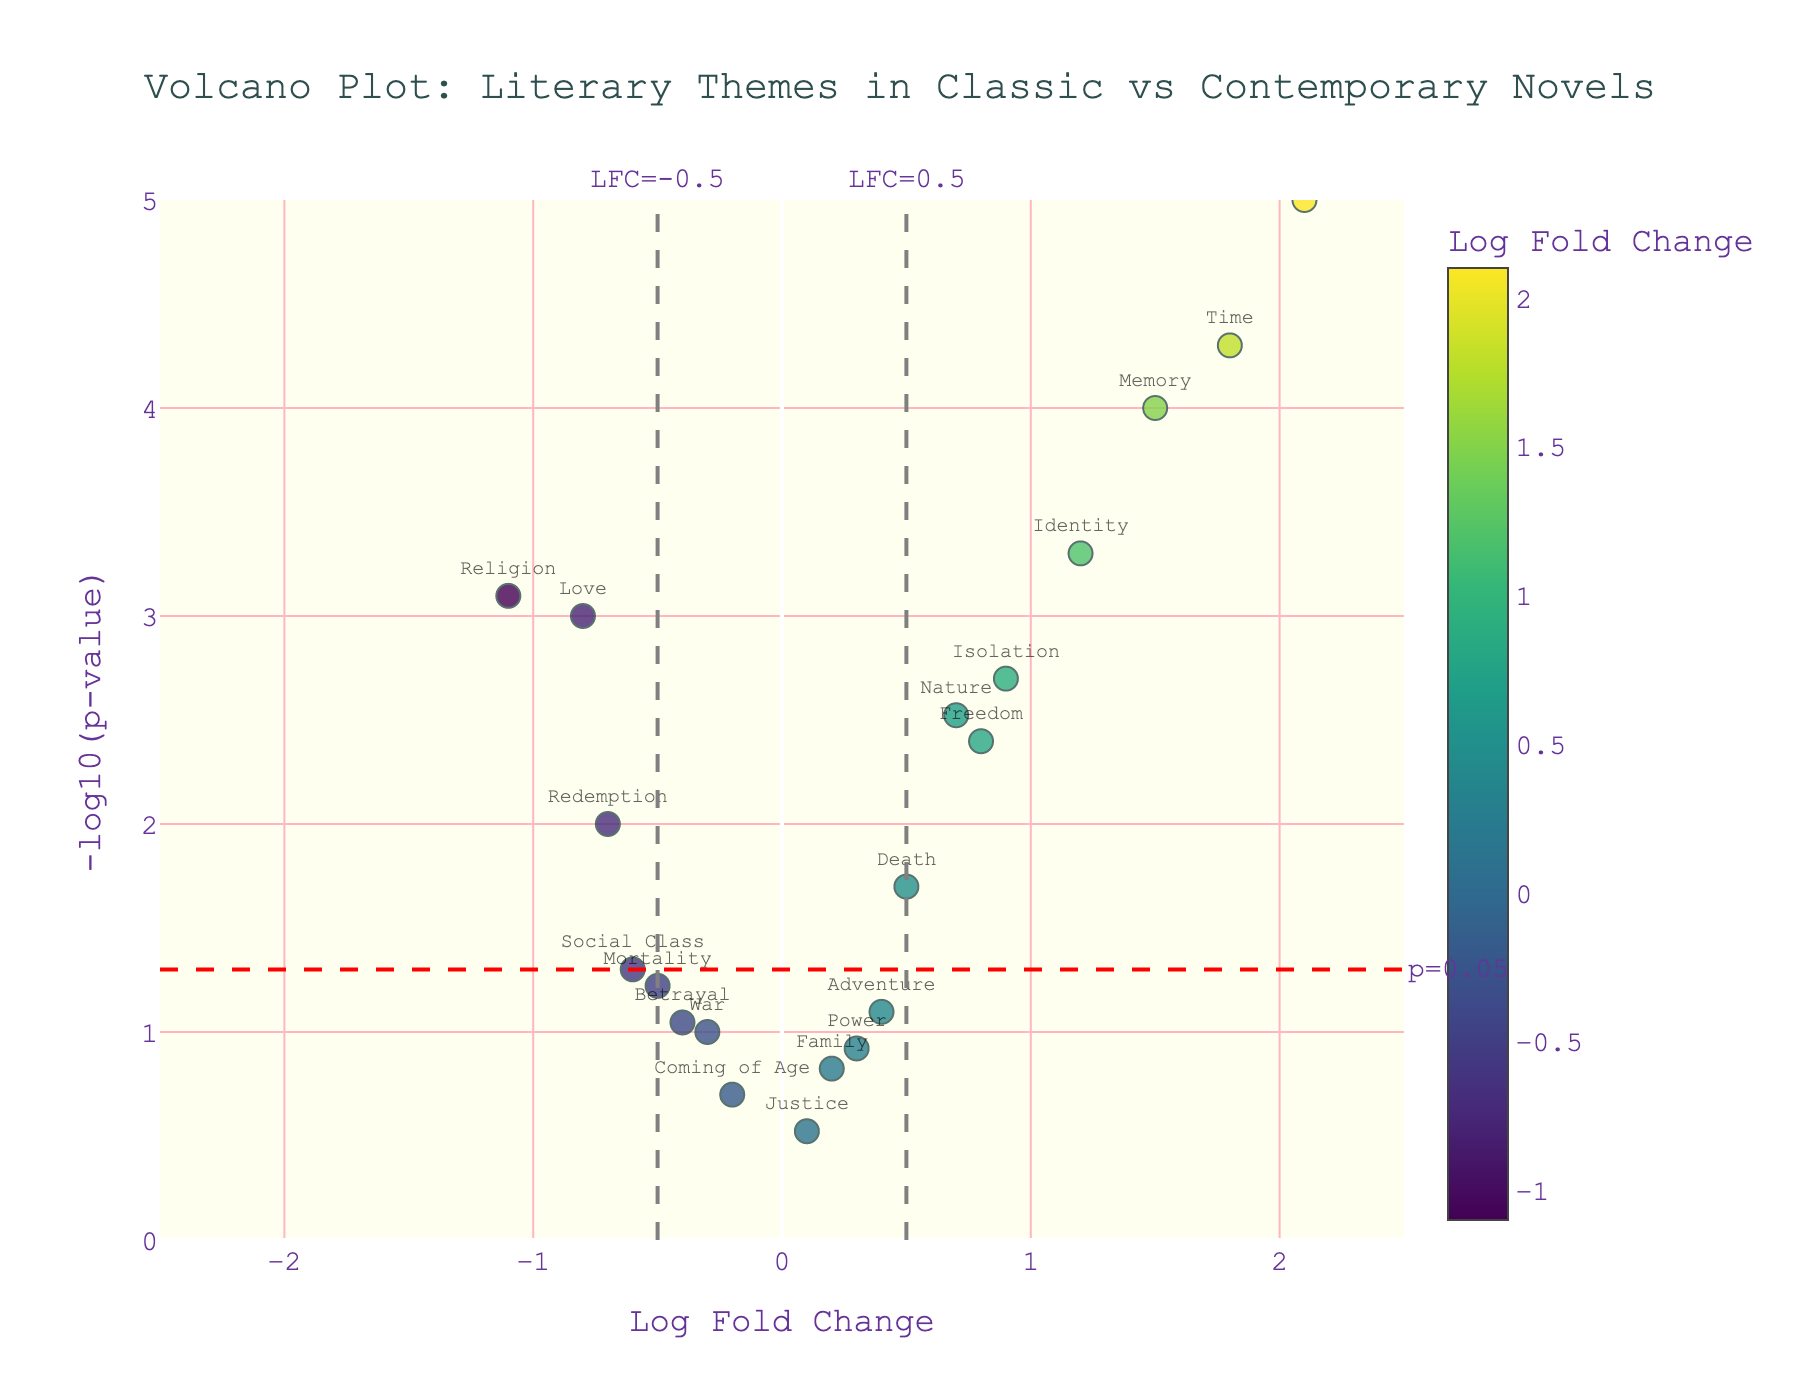What is the title of the plot? The title is displayed at the top center of the figure. It reads: "Volcano Plot: Literary Themes in Classic vs Contemporary Novels."
Answer: Volcano Plot: Literary Themes in Classic vs Contemporary Novels Which theme has the highest Log Fold Change? According to the x-axis, the theme with the highest Log Fold Change is "Technology" with a value of 2.1.
Answer: Technology What are the themes located at the top of the plot with high significance? High significance means low p-values, which are represented by high -log10(p) values on the y-axis. Themes like "Technology" and "Time" are at the top, indicating high significance.
Answer: Technology, Time Which themes lie outside the threshold lines of LFC = -0.5 and LFC = 0.5? Themes outside these lines have Log Fold Changes less than -0.5 or greater than 0.5. They include "Religion" and "Redemption" on the negative side, and "Technology," "Identity," "Memory," and "Time" on the positive side.
Answer: Religion, Redemption, Technology, Identity, Memory, Time What is the Log Fold Change value for the theme "War"? Locate "War" on the x-axis. Its Log Fold Change value is -0.3.
Answer: -0.3 How many themes have a Log Fold Change greater than 1? By looking at the figure, themes with a Log Fold Change greater than 1 are "Identity," "Technology," "Memory," and "Time." There are four such themes.
Answer: 4 Which theme is closest to the p-value threshold line of 0.05? The threshold line for p=0.05 is highlighted at y=-log10(0.05). The theme "Social Class" lies closest to this line.
Answer: Social Class Compare the significance of the themes "Love" and "Freedom." Which one is more significant? Significance is denoted by higher -log10(p). "Love" has a -log10(p) around 3, while "Freedom" has around 2.4. Hence, "Love" is more significant.
Answer: Love What is the range of the x-axis? The x-axis range is set to display from -2.5 to 2.5, as seen from the figure.
Answer: -2.5 to 2.5 If we define significant themes as those with -log10(p) > 1.3, how many significant themes are there? -log10(0.05) = 1.3, so any point with y above this line is significant. Count the themes above this line: "Love," "Death," "Identity," "Nature," "Technology," "Religion," "Isolation," "Memory," "Freedom," "Time," and "Redemption." There are 11 significant themes.
Answer: 11 